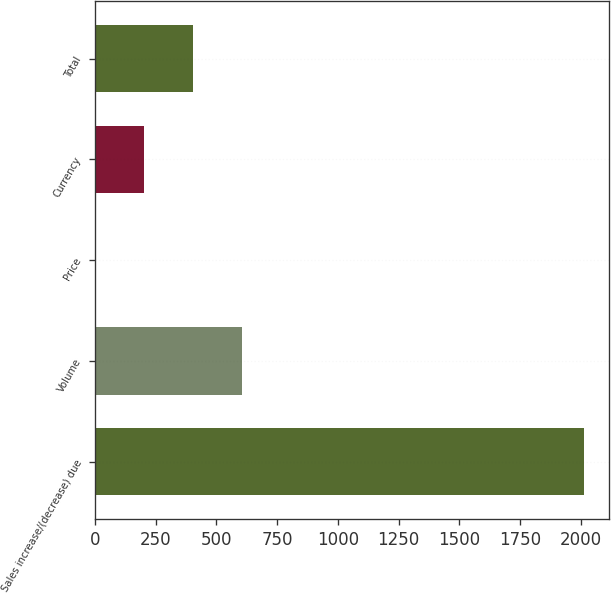Convert chart. <chart><loc_0><loc_0><loc_500><loc_500><bar_chart><fcel>Sales increase/(decrease) due<fcel>Volume<fcel>Price<fcel>Currency<fcel>Total<nl><fcel>2016<fcel>605.29<fcel>0.7<fcel>202.23<fcel>403.76<nl></chart> 